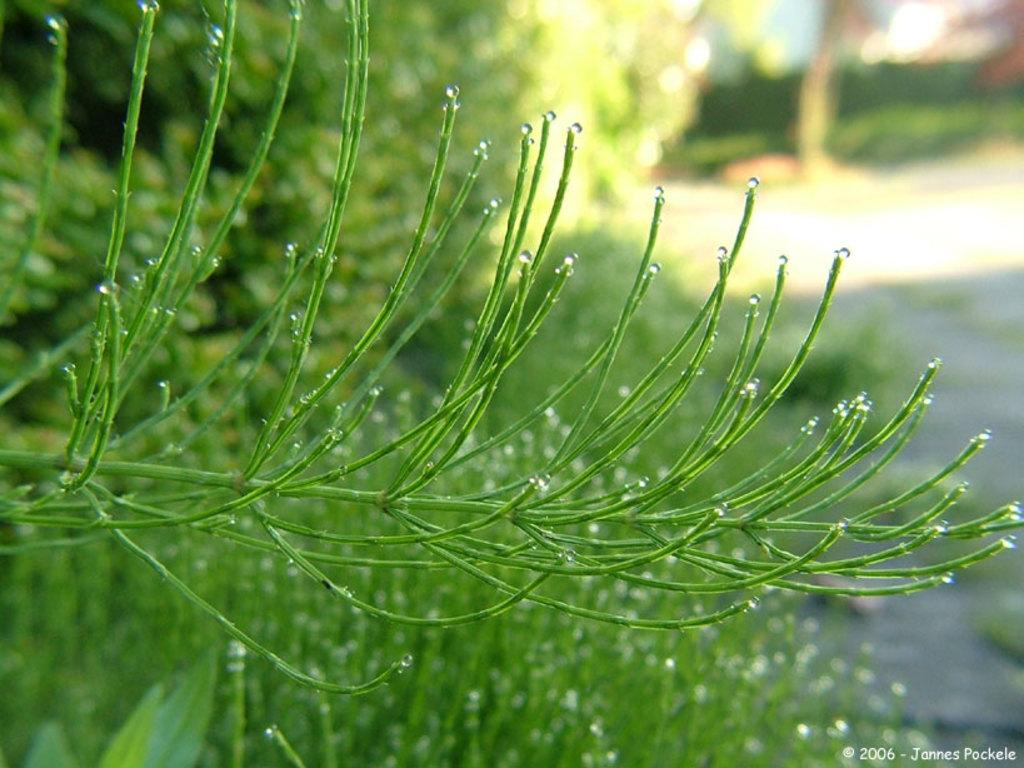What is the main object in the image? There is a stem in the image. What can be seen in the background of the image? There are trees behind the stem. What is the setting behind the stem? There is a pat behind the stem. Is there any additional information or marking on the image? The image has a watermark. What is the rate of the chickens running in the image? There are no chickens present in the image, so there is no rate of chickens running. 